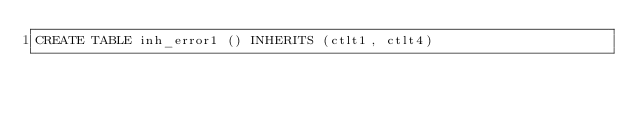<code> <loc_0><loc_0><loc_500><loc_500><_SQL_>CREATE TABLE inh_error1 () INHERITS (ctlt1, ctlt4)
</code> 